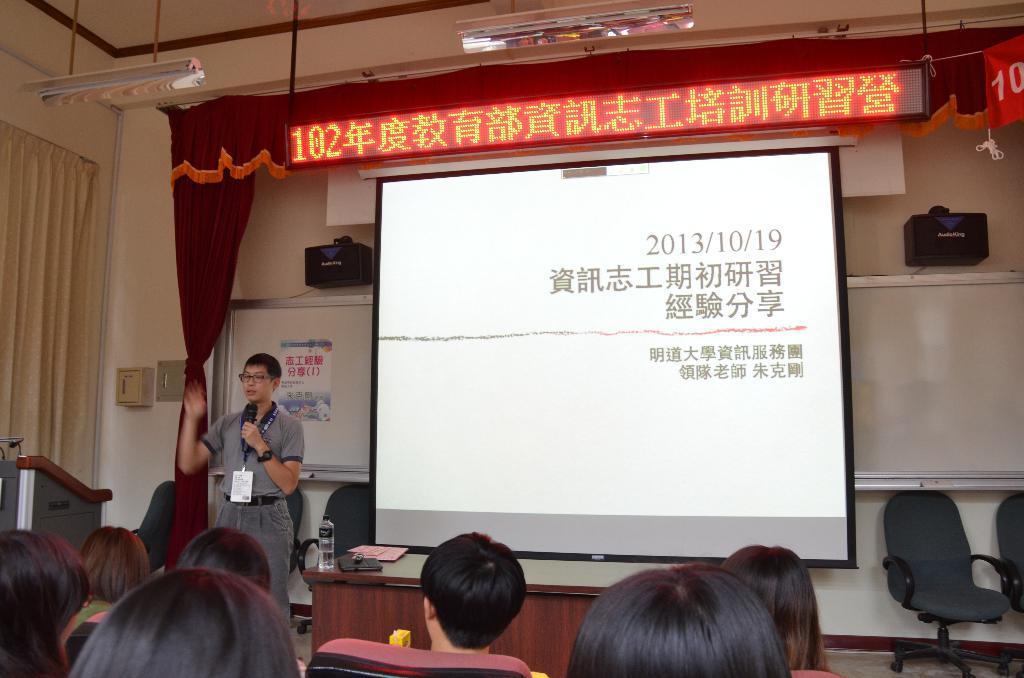Can you describe this image briefly? At the bottom of the picture, we see people sitting on the chairs. In front of them, the man in grey T-shirt who is wearing ID card is holding a microphone in his hand. He is talking on the microphone. Beside him, we see a table on which book, water bottle and a landline phone are placed. Behind that, we see a projector screen and a white color board. Beside that, we see a brown color curtain and a board with some text displayed on it. On the left side, we see a white curtain and a podium. On the right side, we see chairs. This picture is clicked in the conference hall. 